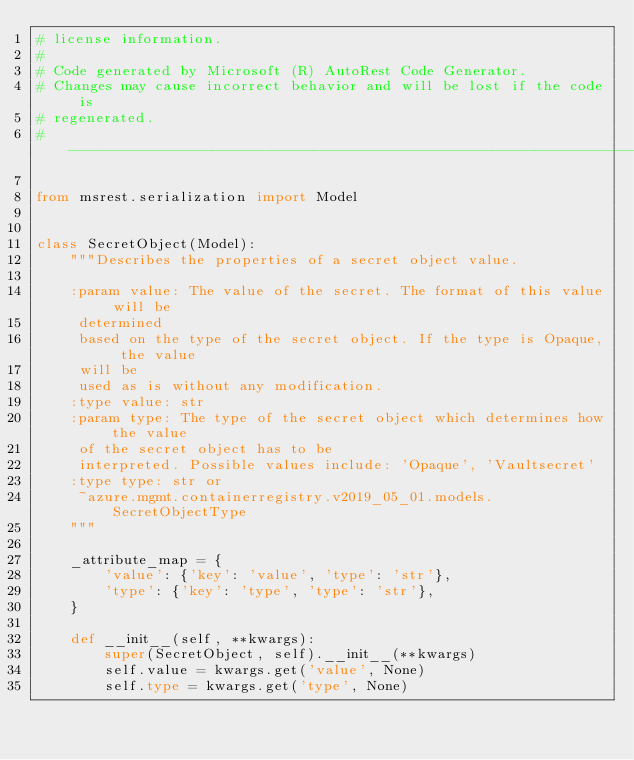Convert code to text. <code><loc_0><loc_0><loc_500><loc_500><_Python_># license information.
#
# Code generated by Microsoft (R) AutoRest Code Generator.
# Changes may cause incorrect behavior and will be lost if the code is
# regenerated.
# --------------------------------------------------------------------------

from msrest.serialization import Model


class SecretObject(Model):
    """Describes the properties of a secret object value.

    :param value: The value of the secret. The format of this value will be
     determined
     based on the type of the secret object. If the type is Opaque, the value
     will be
     used as is without any modification.
    :type value: str
    :param type: The type of the secret object which determines how the value
     of the secret object has to be
     interpreted. Possible values include: 'Opaque', 'Vaultsecret'
    :type type: str or
     ~azure.mgmt.containerregistry.v2019_05_01.models.SecretObjectType
    """

    _attribute_map = {
        'value': {'key': 'value', 'type': 'str'},
        'type': {'key': 'type', 'type': 'str'},
    }

    def __init__(self, **kwargs):
        super(SecretObject, self).__init__(**kwargs)
        self.value = kwargs.get('value', None)
        self.type = kwargs.get('type', None)
</code> 